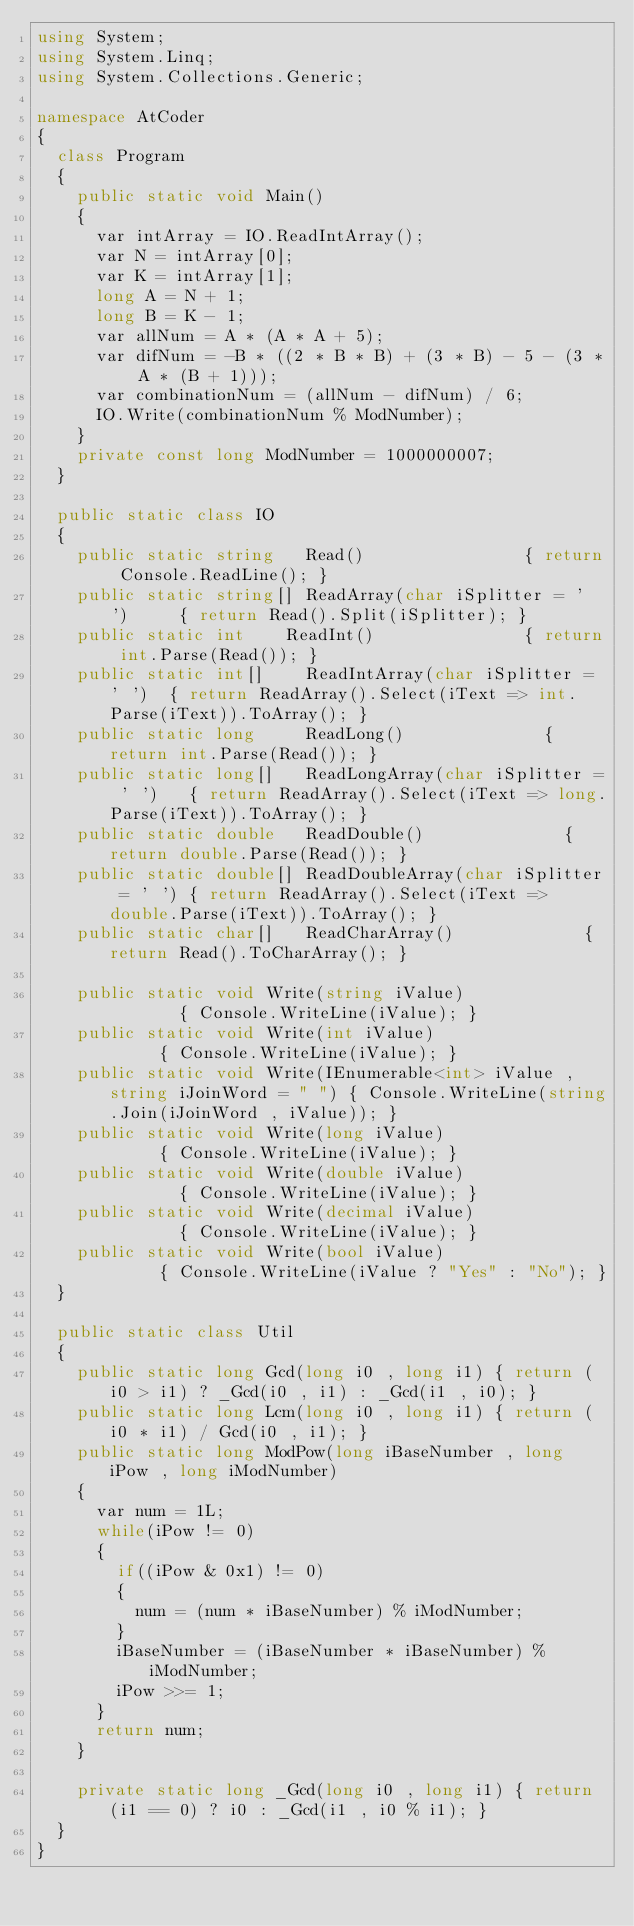Convert code to text. <code><loc_0><loc_0><loc_500><loc_500><_C#_>using System;
using System.Linq;
using System.Collections.Generic;

namespace AtCoder
{
	class Program
	{
		public static void Main()
		{
			var intArray = IO.ReadIntArray();
			var N = intArray[0];
			var K = intArray[1];
			long A = N + 1;
			long B = K - 1;
			var allNum = A * (A * A + 5);
			var difNum = -B * ((2 * B * B) + (3 * B) - 5 - (3 * A * (B + 1)));
			var combinationNum = (allNum - difNum) / 6;
			IO.Write(combinationNum % ModNumber);
		}
		private const long ModNumber = 1000000007;
	}

	public static class IO
	{
		public static string   Read()								 { return Console.ReadLine(); }
		public static string[] ReadArray(char iSplitter = ' ')		 { return Read().Split(iSplitter); }
		public static int	   ReadInt()							 { return int.Parse(Read()); }
		public static int[]	   ReadIntArray(char iSplitter = ' ')	 { return ReadArray().Select(iText => int.Parse(iText)).ToArray(); }
		public static long	   ReadLong()							 { return int.Parse(Read()); }
		public static long[]   ReadLongArray(char iSplitter = ' ')	 { return ReadArray().Select(iText => long.Parse(iText)).ToArray(); }
		public static double   ReadDouble()							 { return double.Parse(Read()); }
		public static double[] ReadDoubleArray(char iSplitter = ' ') { return ReadArray().Select(iText => double.Parse(iText)).ToArray(); }
		public static char[]   ReadCharArray()						 { return Read().ToCharArray(); }

		public static void Write(string iValue)									   { Console.WriteLine(iValue); }
		public static void Write(int iValue)									   { Console.WriteLine(iValue); }
		public static void Write(IEnumerable<int> iValue , string iJoinWord = " ") { Console.WriteLine(string.Join(iJoinWord , iValue)); }
		public static void Write(long iValue)									   { Console.WriteLine(iValue); }
		public static void Write(double iValue)									   { Console.WriteLine(iValue); }
		public static void Write(decimal iValue)								   { Console.WriteLine(iValue); }
		public static void Write(bool iValue)									   { Console.WriteLine(iValue ? "Yes" : "No"); }
	}

	public static class Util
	{
		public static long Gcd(long i0 , long i1) { return (i0 > i1) ? _Gcd(i0 , i1) : _Gcd(i1 , i0); }
		public static long Lcm(long i0 , long i1) { return (i0 * i1) / Gcd(i0 , i1); }
		public static long ModPow(long iBaseNumber , long iPow , long iModNumber)
		{
			var num = 1L;
			while(iPow != 0)
			{
				if((iPow & 0x1) != 0)
				{
					num = (num * iBaseNumber) % iModNumber;
				}
				iBaseNumber = (iBaseNumber * iBaseNumber) % iModNumber;
				iPow >>= 1;
			}
			return num;
		}

		private static long _Gcd(long i0 , long i1)	{ return (i1 == 0) ? i0 : _Gcd(i1 , i0 % i1); }
	}
}
</code> 